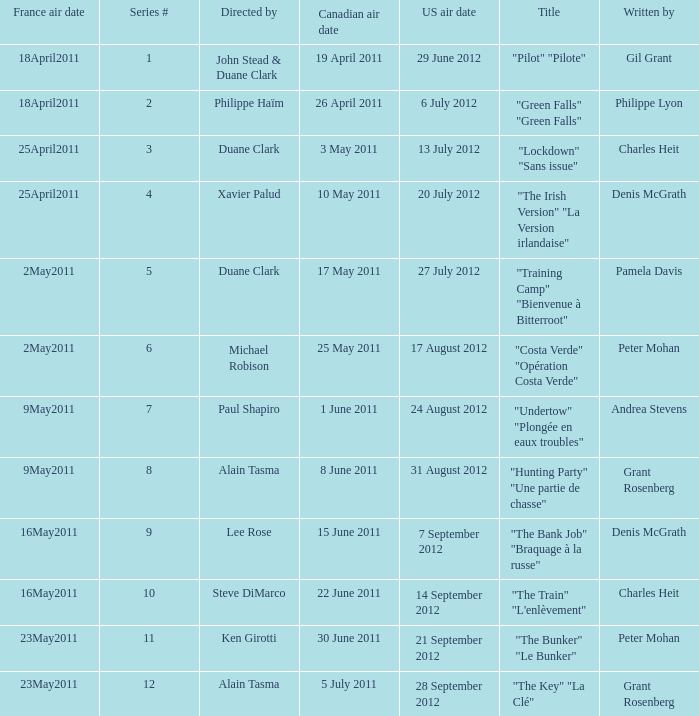What is the canadian air date when the US air date is 24 august 2012? 1 June 2011. 